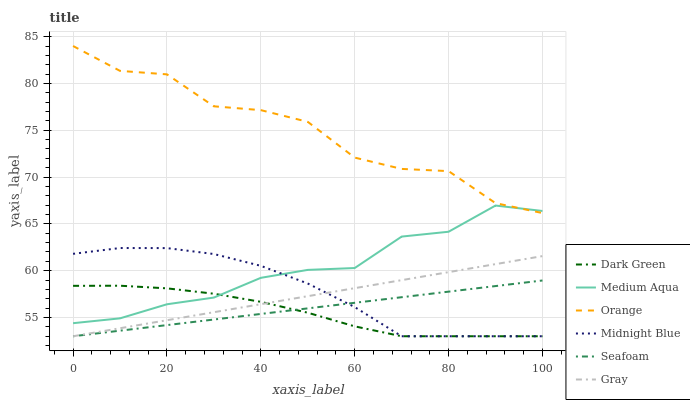Does Dark Green have the minimum area under the curve?
Answer yes or no. Yes. Does Orange have the maximum area under the curve?
Answer yes or no. Yes. Does Midnight Blue have the minimum area under the curve?
Answer yes or no. No. Does Midnight Blue have the maximum area under the curve?
Answer yes or no. No. Is Seafoam the smoothest?
Answer yes or no. Yes. Is Orange the roughest?
Answer yes or no. Yes. Is Midnight Blue the smoothest?
Answer yes or no. No. Is Midnight Blue the roughest?
Answer yes or no. No. Does Gray have the lowest value?
Answer yes or no. Yes. Does Medium Aqua have the lowest value?
Answer yes or no. No. Does Orange have the highest value?
Answer yes or no. Yes. Does Midnight Blue have the highest value?
Answer yes or no. No. Is Gray less than Orange?
Answer yes or no. Yes. Is Medium Aqua greater than Seafoam?
Answer yes or no. Yes. Does Seafoam intersect Dark Green?
Answer yes or no. Yes. Is Seafoam less than Dark Green?
Answer yes or no. No. Is Seafoam greater than Dark Green?
Answer yes or no. No. Does Gray intersect Orange?
Answer yes or no. No. 